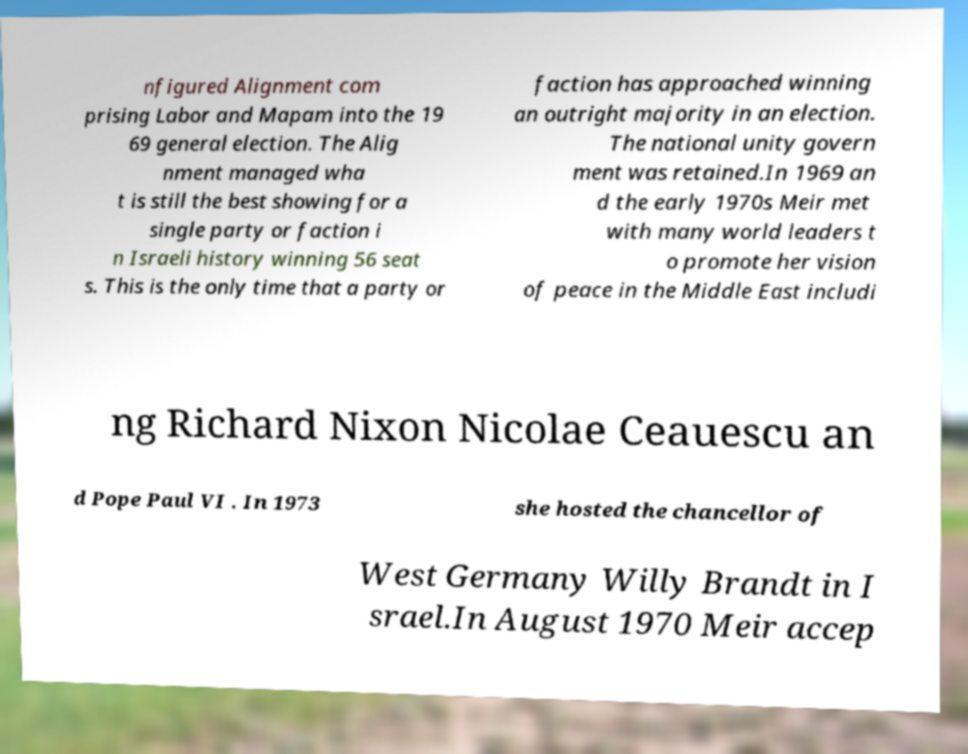I need the written content from this picture converted into text. Can you do that? nfigured Alignment com prising Labor and Mapam into the 19 69 general election. The Alig nment managed wha t is still the best showing for a single party or faction i n Israeli history winning 56 seat s. This is the only time that a party or faction has approached winning an outright majority in an election. The national unity govern ment was retained.In 1969 an d the early 1970s Meir met with many world leaders t o promote her vision of peace in the Middle East includi ng Richard Nixon Nicolae Ceauescu an d Pope Paul VI . In 1973 she hosted the chancellor of West Germany Willy Brandt in I srael.In August 1970 Meir accep 